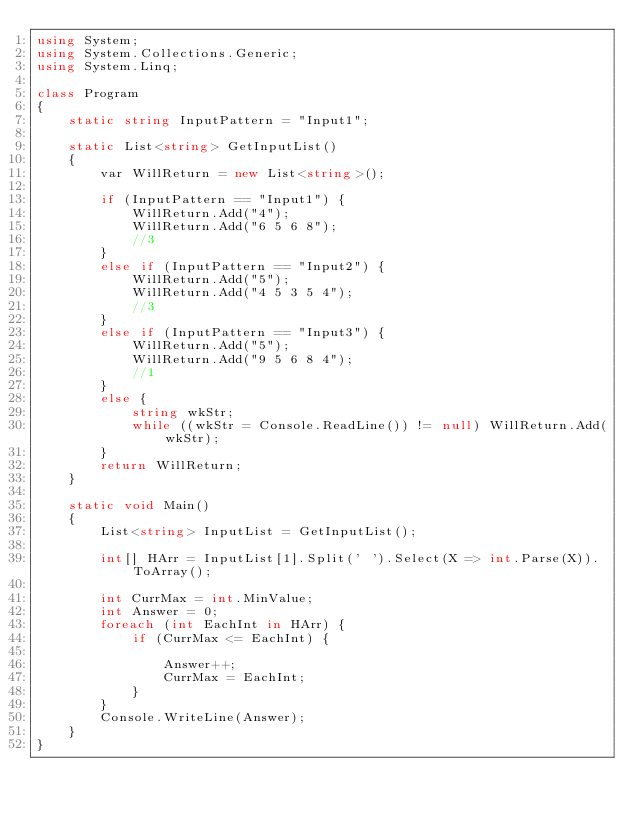Convert code to text. <code><loc_0><loc_0><loc_500><loc_500><_C#_>using System;
using System.Collections.Generic;
using System.Linq;

class Program
{
    static string InputPattern = "Input1";

    static List<string> GetInputList()
    {
        var WillReturn = new List<string>();

        if (InputPattern == "Input1") {
            WillReturn.Add("4");
            WillReturn.Add("6 5 6 8");
            //3
        }
        else if (InputPattern == "Input2") {
            WillReturn.Add("5");
            WillReturn.Add("4 5 3 5 4");
            //3
        }
        else if (InputPattern == "Input3") {
            WillReturn.Add("5");
            WillReturn.Add("9 5 6 8 4");
            //1
        }
        else {
            string wkStr;
            while ((wkStr = Console.ReadLine()) != null) WillReturn.Add(wkStr);
        }
        return WillReturn;
    }

    static void Main()
    {
        List<string> InputList = GetInputList();

        int[] HArr = InputList[1].Split(' ').Select(X => int.Parse(X)).ToArray();

        int CurrMax = int.MinValue;
        int Answer = 0;
        foreach (int EachInt in HArr) {
            if (CurrMax <= EachInt) {

                Answer++;
                CurrMax = EachInt;
            }
        }
        Console.WriteLine(Answer);
    }
}
</code> 